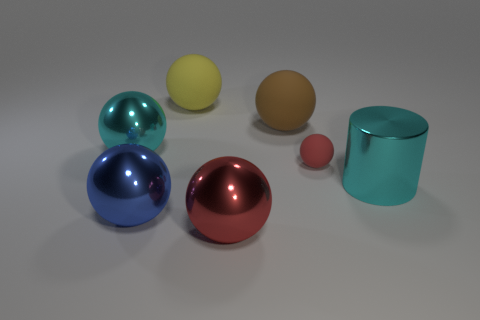Subtract all cyan shiny balls. How many balls are left? 5 Add 3 small yellow rubber spheres. How many objects exist? 10 Subtract all cylinders. How many objects are left? 6 Subtract all cyan shiny objects. Subtract all blue things. How many objects are left? 4 Add 7 tiny matte objects. How many tiny matte objects are left? 8 Add 2 yellow matte objects. How many yellow matte objects exist? 3 Subtract all brown balls. How many balls are left? 5 Subtract 0 green balls. How many objects are left? 7 Subtract all gray balls. Subtract all blue cylinders. How many balls are left? 6 Subtract all yellow cylinders. How many cyan balls are left? 1 